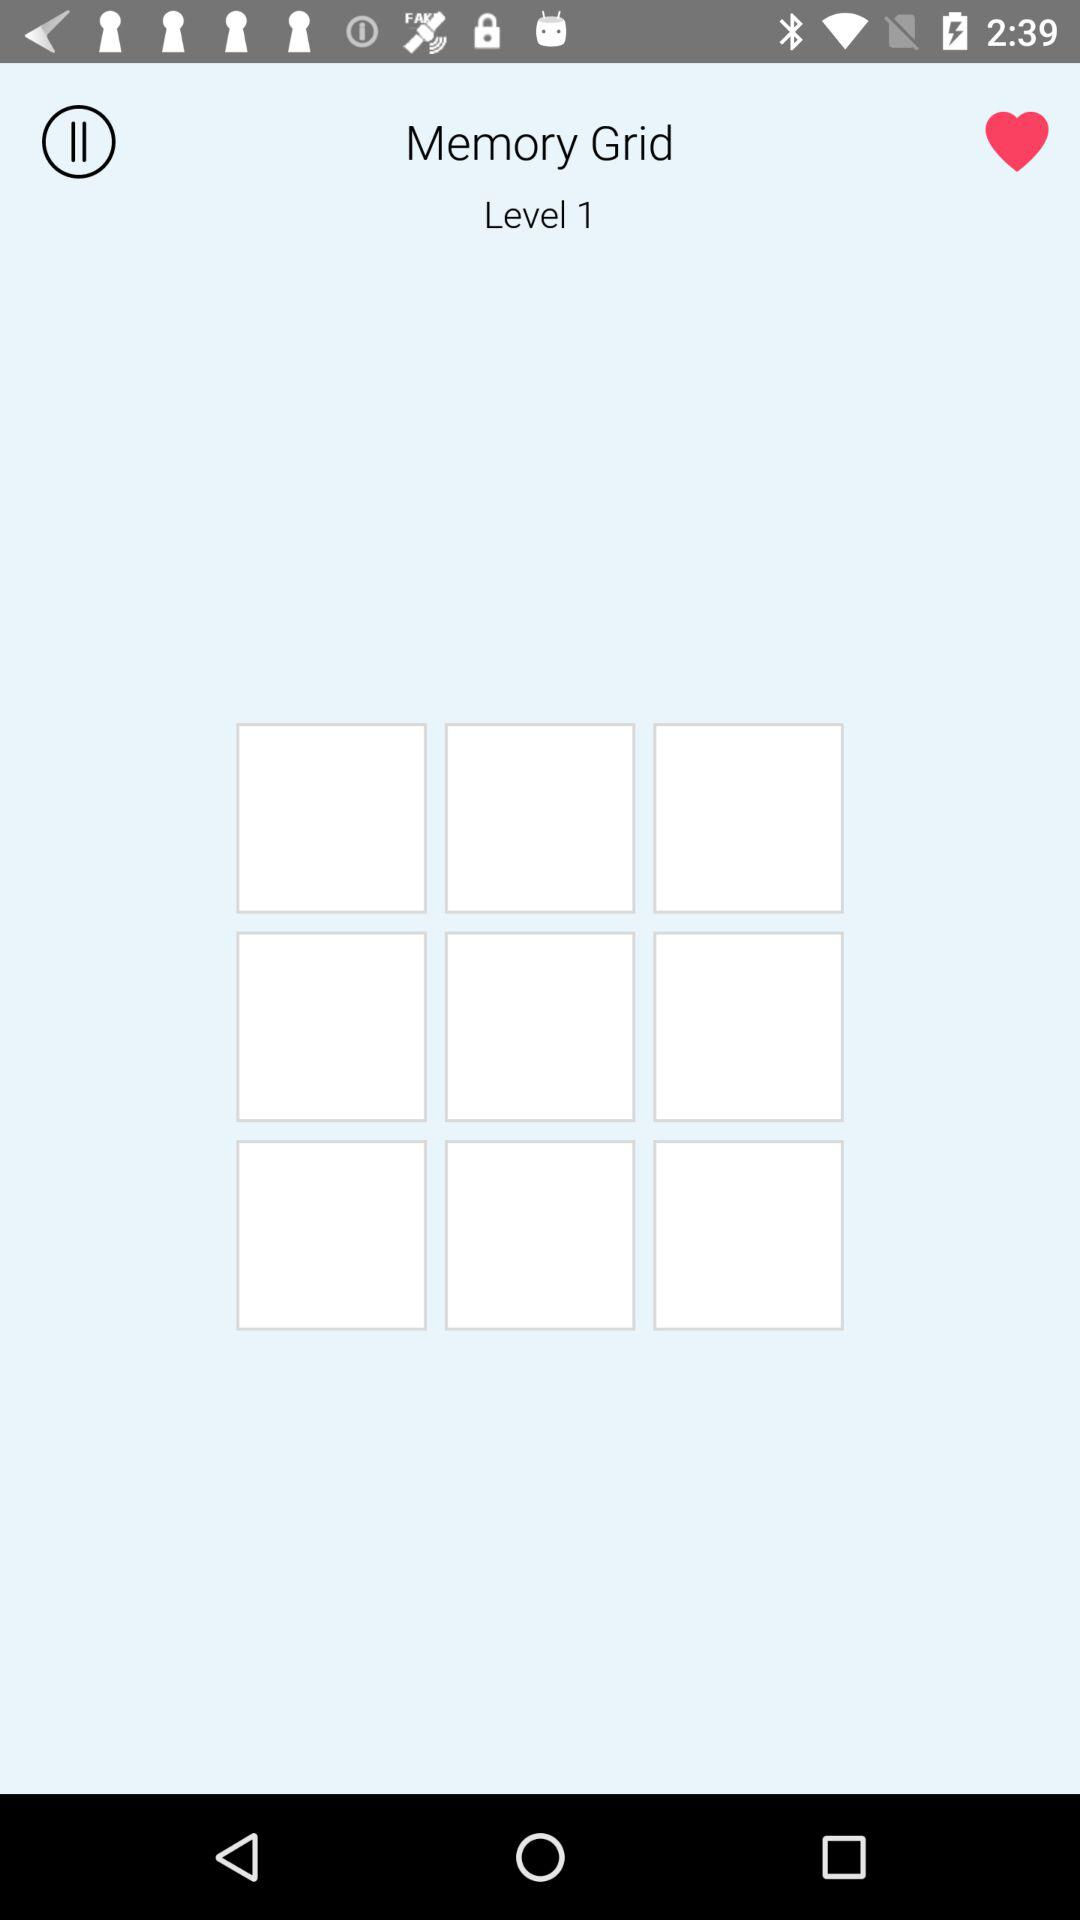How many white rectangles are there on the level?
Answer the question using a single word or phrase. 9 